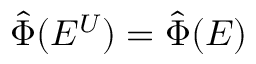<formula> <loc_0><loc_0><loc_500><loc_500>\hat { \Phi } ( E ^ { U } ) = \hat { \Phi } ( E )</formula> 